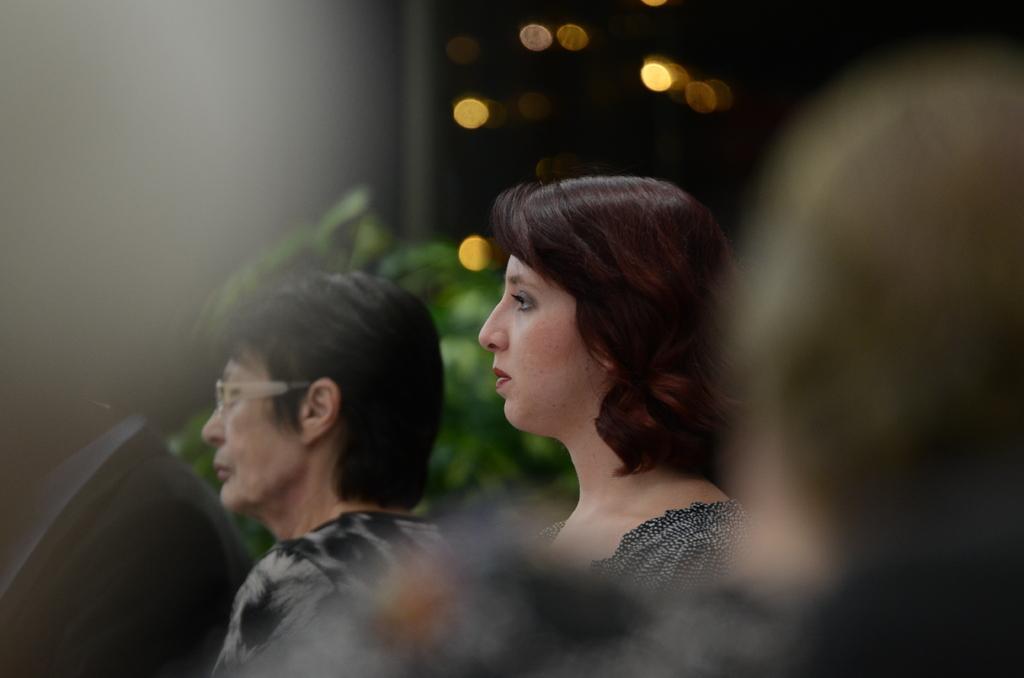Can you describe this image briefly? In this image we can see people. In the background of the image there are plants and lights. 